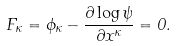Convert formula to latex. <formula><loc_0><loc_0><loc_500><loc_500>F _ { \kappa } = \phi _ { \kappa } - \frac { \partial \log \psi } { \partial x ^ { \kappa } } = 0 .</formula> 